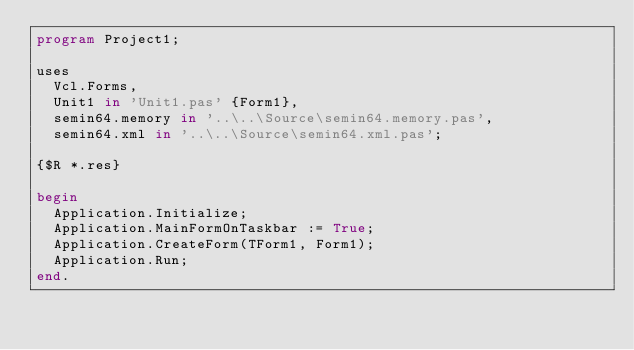<code> <loc_0><loc_0><loc_500><loc_500><_Pascal_>program Project1;

uses
  Vcl.Forms,
  Unit1 in 'Unit1.pas' {Form1},
  semin64.memory in '..\..\Source\semin64.memory.pas',
  semin64.xml in '..\..\Source\semin64.xml.pas';

{$R *.res}

begin
  Application.Initialize;
  Application.MainFormOnTaskbar := True;
  Application.CreateForm(TForm1, Form1);
  Application.Run;
end.
</code> 